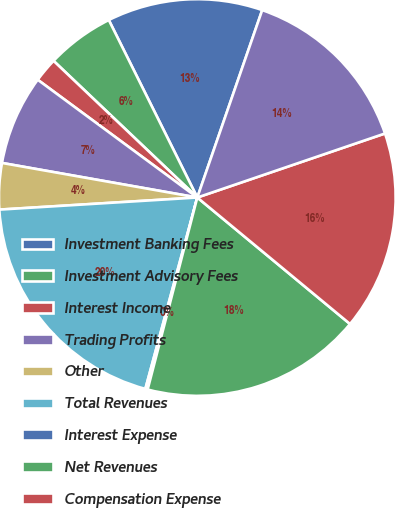Convert chart. <chart><loc_0><loc_0><loc_500><loc_500><pie_chart><fcel>Investment Banking Fees<fcel>Investment Advisory Fees<fcel>Interest Income<fcel>Trading Profits<fcel>Other<fcel>Total Revenues<fcel>Interest Expense<fcel>Net Revenues<fcel>Compensation Expense<fcel>Other Expense<nl><fcel>12.67%<fcel>5.54%<fcel>1.98%<fcel>7.33%<fcel>3.76%<fcel>19.81%<fcel>0.19%<fcel>18.02%<fcel>16.24%<fcel>14.46%<nl></chart> 